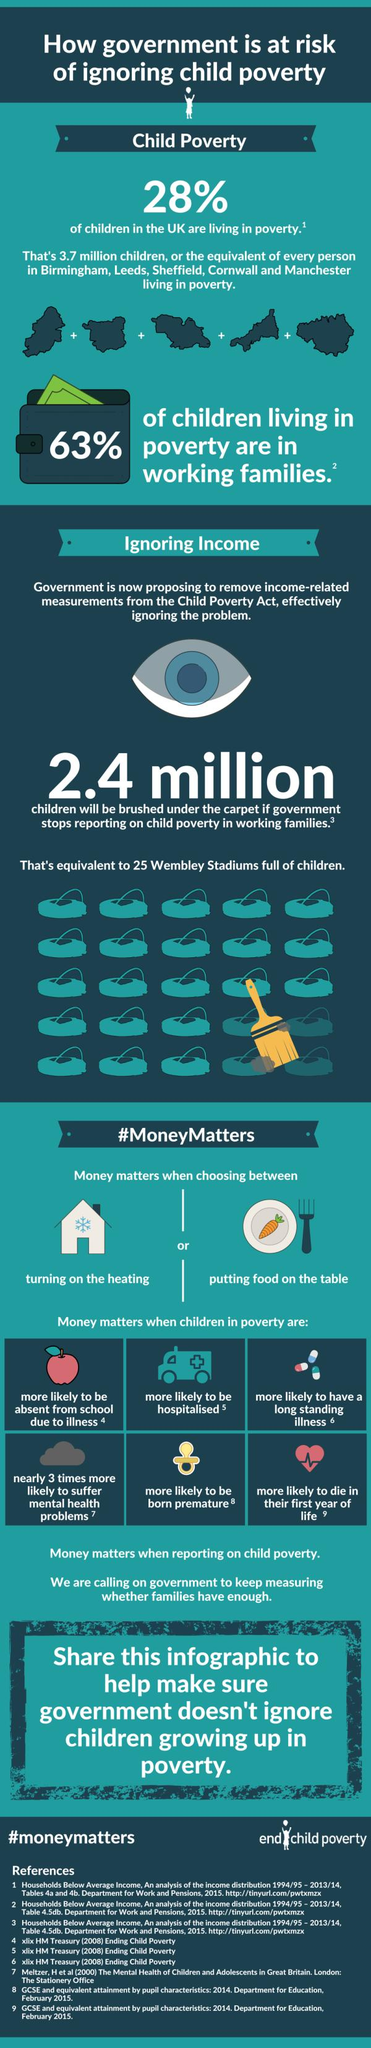Identify some key points in this picture. According to recent data, 72% of children in the UK are not living in poverty, demonstrating a significant improvement in the overall well-being of young people in the country. According to statistics, 37% of children living in poverty come from workless families. The hashtag used to end child poverty is #moneymatters. 